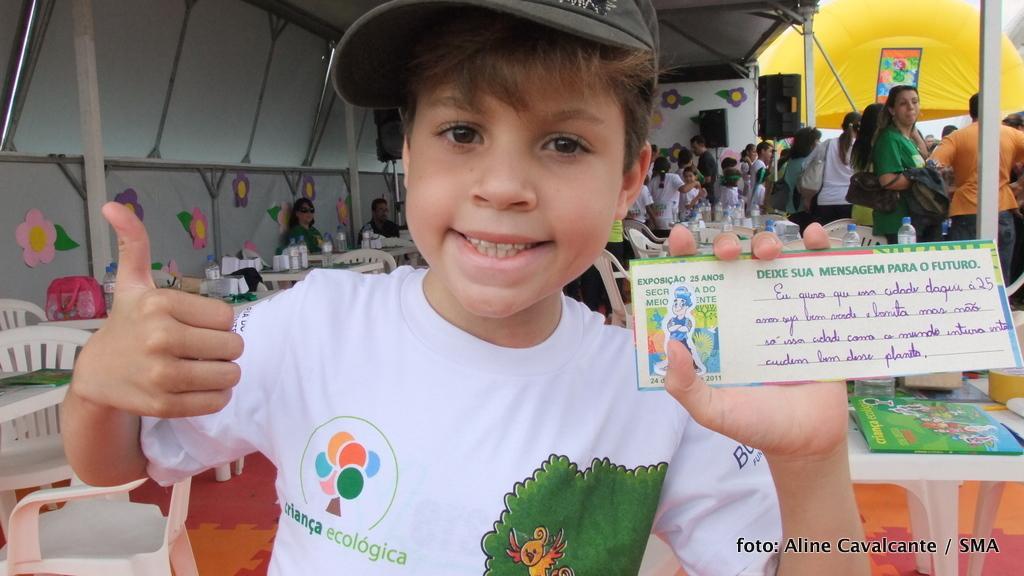In one or two sentences, can you explain what this image depicts? In this image we can see a child standing and holding a card in his hands. In the background we can see persons sitting on the chairs and tables are placed in front of them. On the tables we can see cartons and disposal bottles. On the other side we can see persons standing on the floor, tents, poles, speakers and books. 